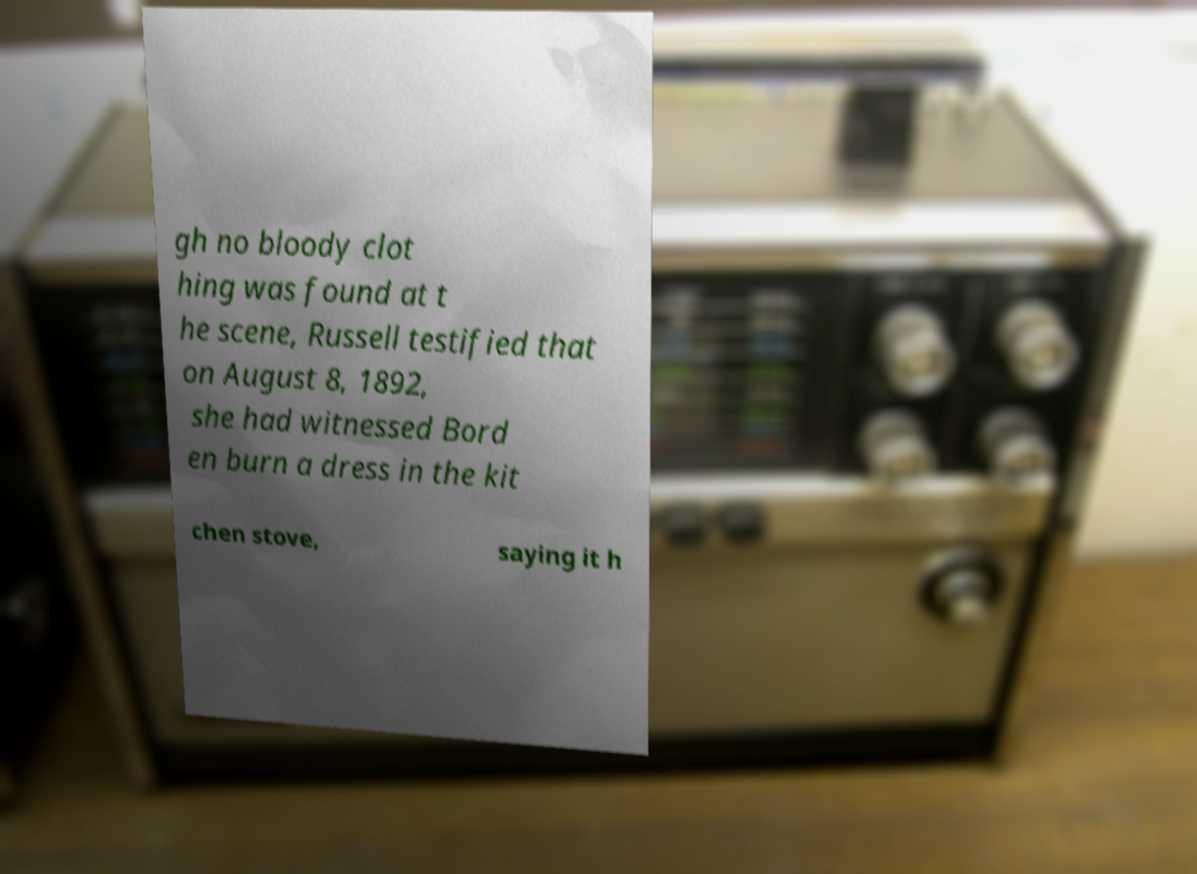What messages or text are displayed in this image? I need them in a readable, typed format. gh no bloody clot hing was found at t he scene, Russell testified that on August 8, 1892, she had witnessed Bord en burn a dress in the kit chen stove, saying it h 